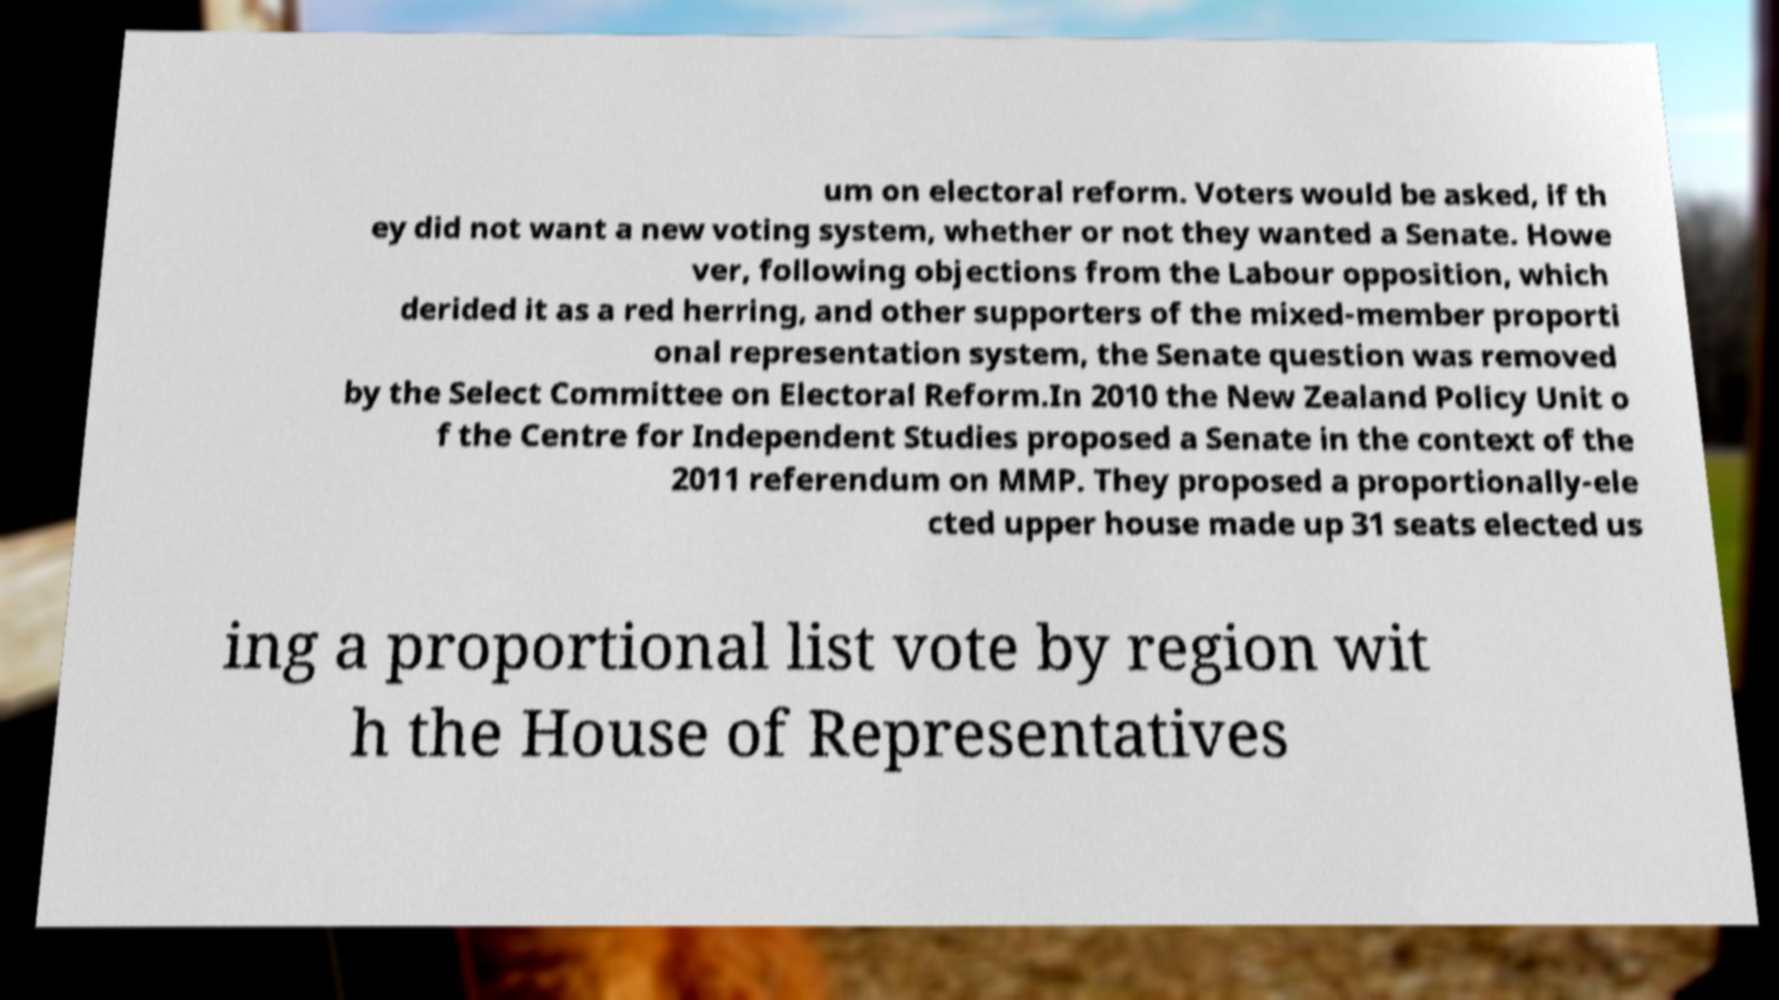Can you accurately transcribe the text from the provided image for me? um on electoral reform. Voters would be asked, if th ey did not want a new voting system, whether or not they wanted a Senate. Howe ver, following objections from the Labour opposition, which derided it as a red herring, and other supporters of the mixed-member proporti onal representation system, the Senate question was removed by the Select Committee on Electoral Reform.In 2010 the New Zealand Policy Unit o f the Centre for Independent Studies proposed a Senate in the context of the 2011 referendum on MMP. They proposed a proportionally-ele cted upper house made up 31 seats elected us ing a proportional list vote by region wit h the House of Representatives 